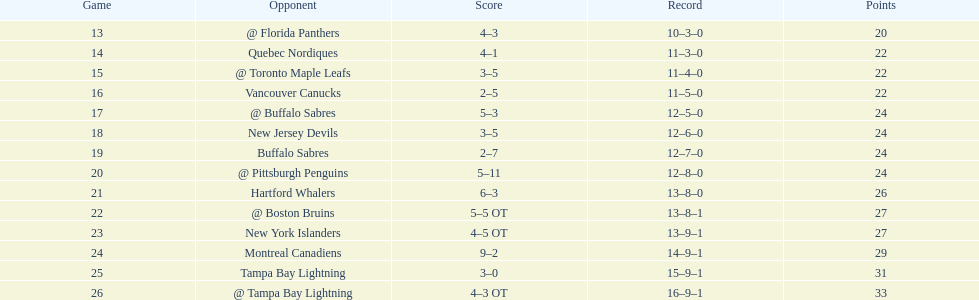Were the new jersey devils in last place according to the chart? No. 